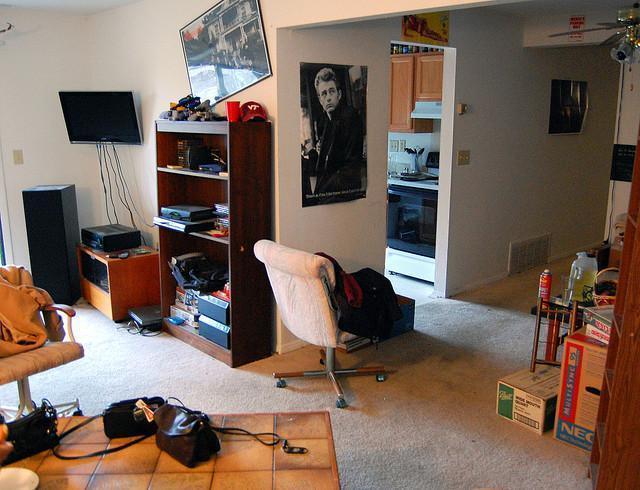How many handbags are in the photo?
Give a very brief answer. 2. How many tvs are there?
Give a very brief answer. 1. How many chairs are there?
Give a very brief answer. 2. 